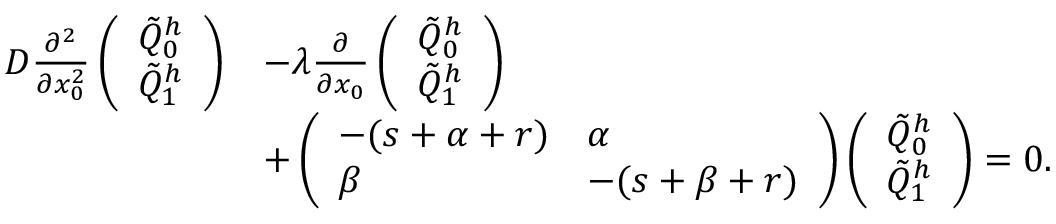<formula> <loc_0><loc_0><loc_500><loc_500>\begin{array} { r l } { D \frac { \partial ^ { 2 } } { \partial x _ { 0 } ^ { 2 } } \left ( \begin{array} { l } { \tilde { Q } _ { 0 } ^ { h } } \\ { \tilde { Q } _ { 1 } ^ { h } } \end{array} \right ) } & { - \lambda \frac { \partial } { \partial x _ { 0 } } \left ( \begin{array} { l } { \tilde { Q } _ { 0 } ^ { h } } \\ { \tilde { Q } _ { 1 } ^ { h } } \end{array} \right ) } \\ & { + \left ( \begin{array} { l l } { - ( s + \alpha + r ) } & { \alpha } \\ { \beta } & { - ( s + \beta + r ) } \end{array} \right ) \left ( \begin{array} { l } { \tilde { Q } _ { 0 } ^ { h } } \\ { \tilde { Q } _ { 1 } ^ { h } } \end{array} \right ) = 0 . } \end{array}</formula> 